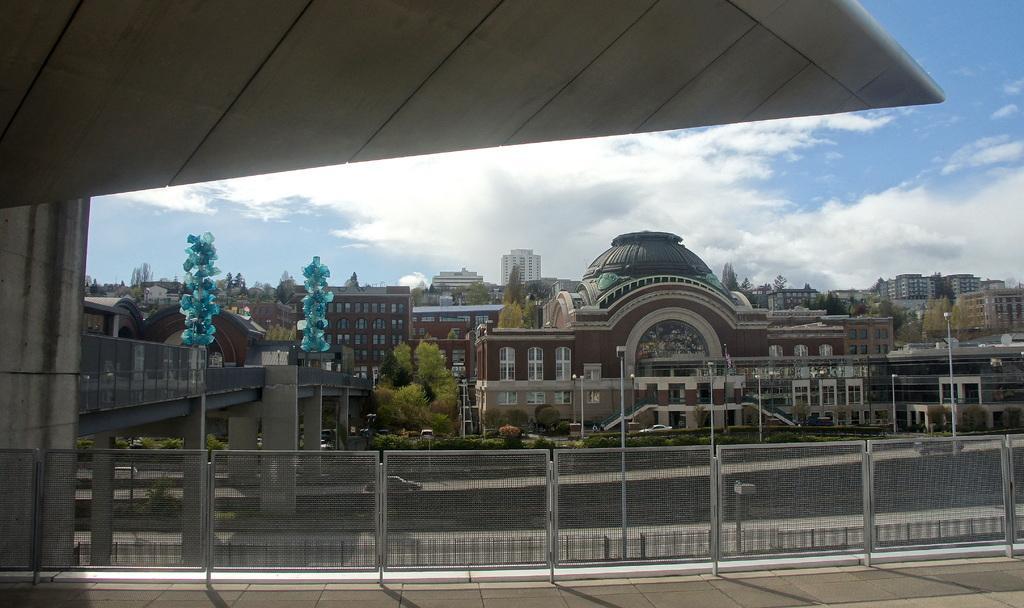Could you give a brief overview of what you see in this image? In this image, we can see gates, buildings, poles, trees and at the top, there are clouds in the sky. 